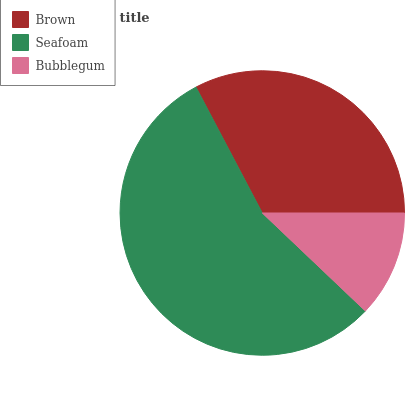Is Bubblegum the minimum?
Answer yes or no. Yes. Is Seafoam the maximum?
Answer yes or no. Yes. Is Seafoam the minimum?
Answer yes or no. No. Is Bubblegum the maximum?
Answer yes or no. No. Is Seafoam greater than Bubblegum?
Answer yes or no. Yes. Is Bubblegum less than Seafoam?
Answer yes or no. Yes. Is Bubblegum greater than Seafoam?
Answer yes or no. No. Is Seafoam less than Bubblegum?
Answer yes or no. No. Is Brown the high median?
Answer yes or no. Yes. Is Brown the low median?
Answer yes or no. Yes. Is Seafoam the high median?
Answer yes or no. No. Is Bubblegum the low median?
Answer yes or no. No. 